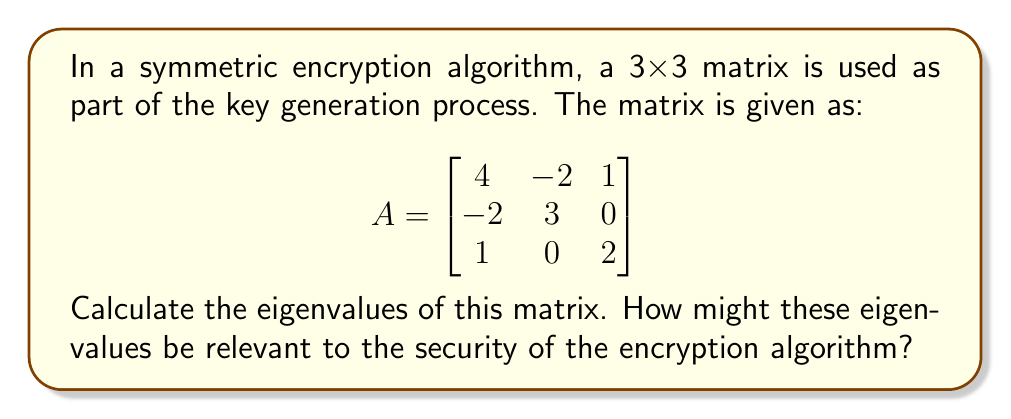What is the answer to this math problem? To find the eigenvalues of matrix A, we need to solve the characteristic equation:

$$det(A - \lambda I) = 0$$

Where $\lambda$ represents the eigenvalues and $I$ is the 3x3 identity matrix.

Step 1: Set up the characteristic equation
$$det\begin{pmatrix}
4-\lambda & -2 & 1 \\
-2 & 3-\lambda & 0 \\
1 & 0 & 2-\lambda
\end{pmatrix} = 0$$

Step 2: Expand the determinant
$$(4-\lambda)(3-\lambda)(2-\lambda) + (-2)(0)(1) + (-2)(1)(0) - (1)(3-\lambda)(1) - (4-\lambda)(0)(0) - (-2)(-2)(2-\lambda) = 0$$

Step 3: Simplify
$$(4-\lambda)(3-\lambda)(2-\lambda) - (3-\lambda) - 4(2-\lambda) = 0$$
$$24 - 12\lambda + 2\lambda^2 - 3\lambda + \lambda^2 - 12 + 3\lambda - 8 + 2\lambda = 0$$

Step 4: Collect terms
$$\lambda^3 - 9\lambda^2 + 23\lambda - 15 = 0$$

Step 5: Solve the cubic equation
Using the cubic formula or a numerical method, we find the roots:

$\lambda_1 = 1$
$\lambda_2 = 3$
$\lambda_3 = 5$

Relevance to security:
1. Eigenvalues can affect the diffusion properties of the encryption algorithm.
2. They may influence the algorithm's resistance to certain cryptanalytic attacks.
3. The distribution and magnitude of eigenvalues can impact the overall strength of the key.
4. In implementations, the eigenvalues might be used to generate additional key material or influence the encryption rounds.

However, as a cybersecurity expert, it's important to note that the security of an encryption algorithm depends more on its overall design and implementation rather than solely on mathematical properties like eigenvalues.
Answer: Eigenvalues: $\lambda_1 = 1$, $\lambda_2 = 3$, $\lambda_3 = 5$ 